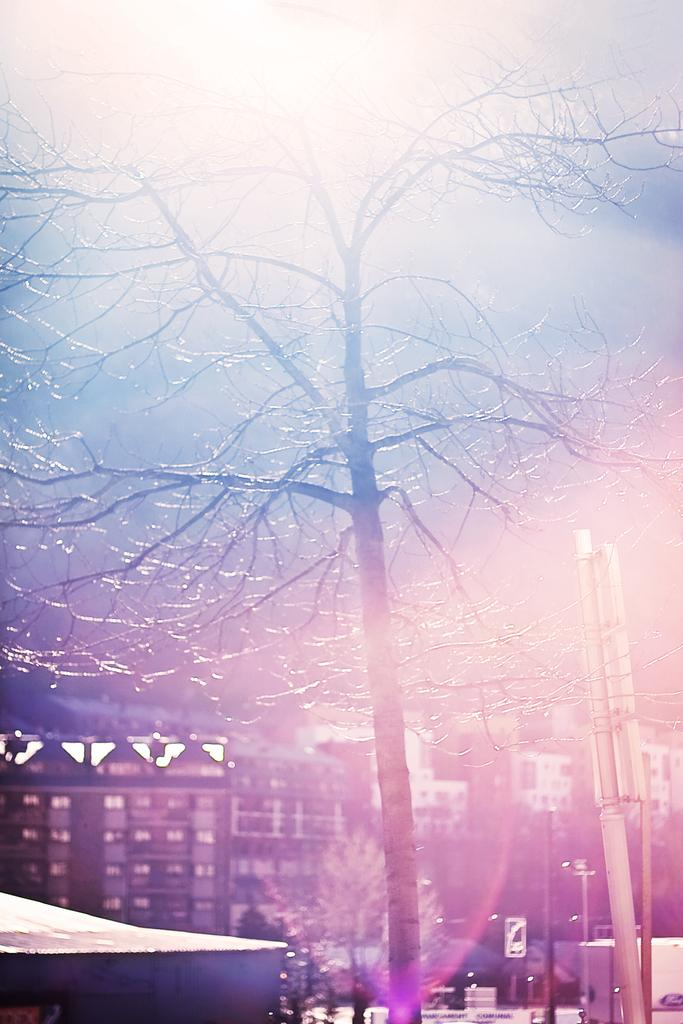What type of natural elements can be seen in the image? There are trees in the image. What man-made objects are present in the image? There are boards and poles in the image. What can be seen in the background of the image? There is a building and the sky visible in the background of the image. What type of silver art can be seen in the image? There is no silver art present in the image. What arithmetic problem is being solved by the trees in the image? The trees in the image are not solving any arithmetic problems; they are simply trees. 